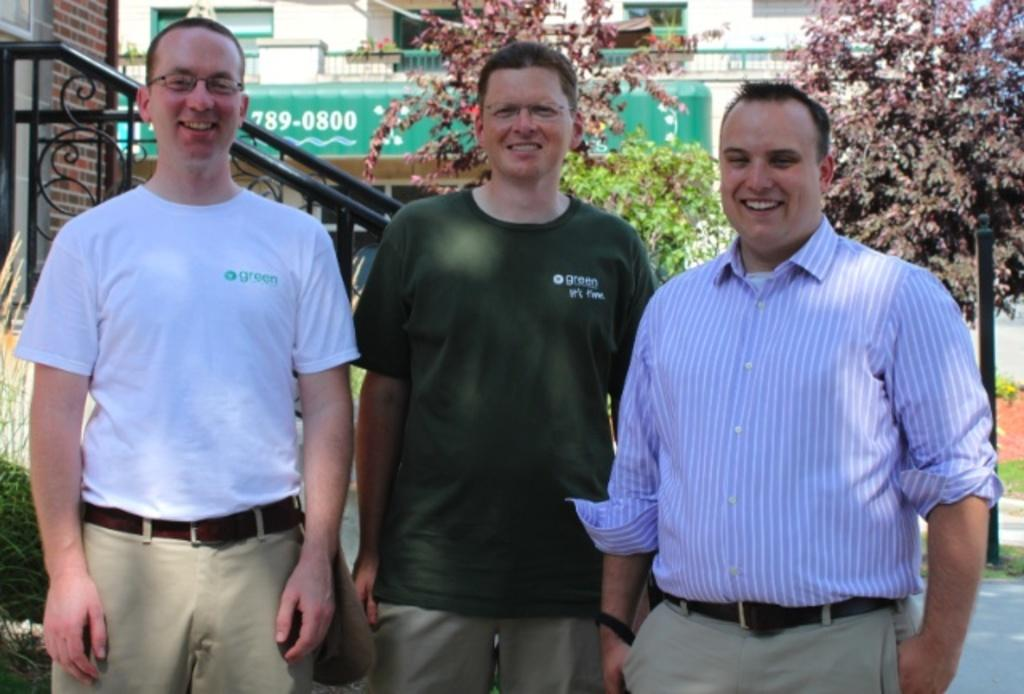How many people are in the image? There are three men in the image. What are the men doing in the image? The men are standing and smiling. What can be seen in the background of the image? There is a building in the background of the image. What is located in the middle of the image? There are trees in the middle of the image. What is on the left side of the image? There is a wall on the left side of the image. What type of robin can be seen singing in the image? There is no robin present in the image; it features three men standing and smiling. What type of pleasure can be seen being experienced by the men in the image? The image does not explicitly show the type of pleasure being experienced by the men, but their smiles may suggest enjoyment or happiness. 